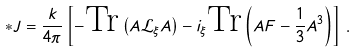<formula> <loc_0><loc_0><loc_500><loc_500>\ast J = \frac { k } { 4 \pi } \left [ - \text {Tr} \left ( A \mathcal { L } _ { \xi } A \right ) - i _ { \xi } \text {Tr} \left ( A F - \frac { 1 } { 3 } A ^ { 3 } \right ) \right ] \, .</formula> 